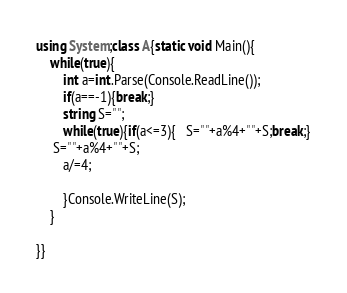<code> <loc_0><loc_0><loc_500><loc_500><_C#_>using System;class A{static void Main(){
    while(true){
        int a=int.Parse(Console.ReadLine());
        if(a==-1){break;}
        string S="";
        while(true){if(a<=3){   S=""+a%4+""+S;break;}
     S=""+a%4+""+S;
        a/=4;
        
        }Console.WriteLine(S);
    }
    
}}</code> 